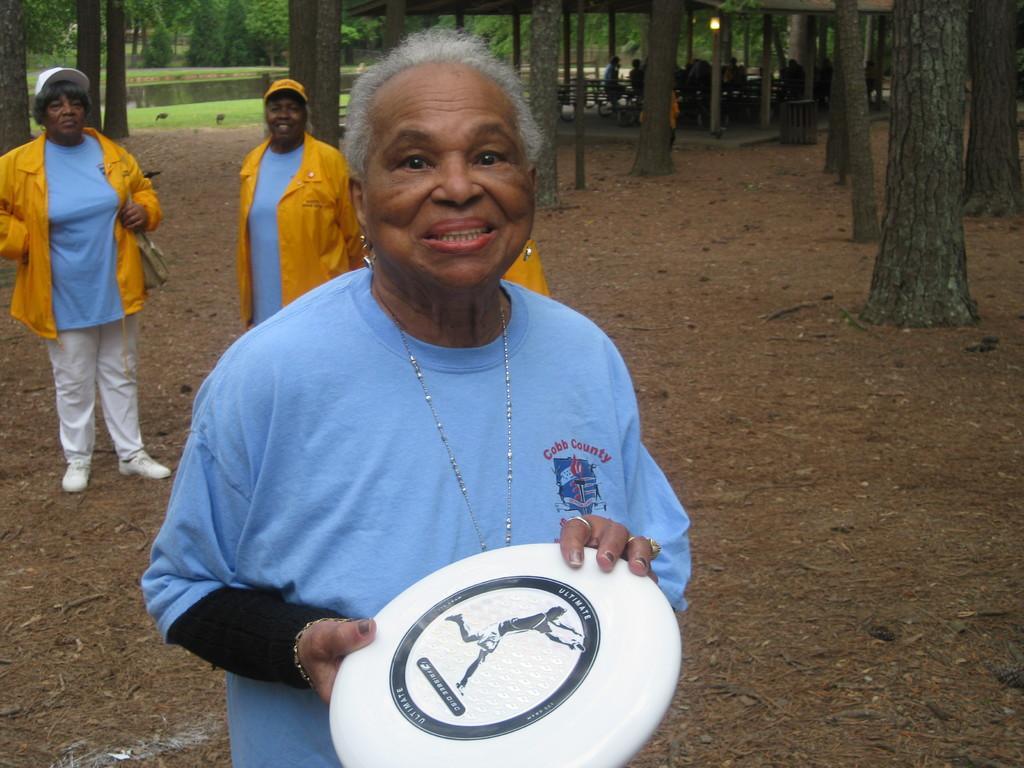Describe this image in one or two sentences. In this image there is a lady standing and holding a disc in her hand, behind her there are few more persons standing on the surface. In the background there are trees, in the middle of the trees there are a few people sitting on the benches in front of the river. 